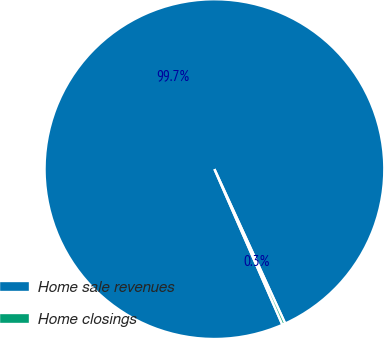Convert chart. <chart><loc_0><loc_0><loc_500><loc_500><pie_chart><fcel>Home sale revenues<fcel>Home closings<nl><fcel>99.71%<fcel>0.29%<nl></chart> 